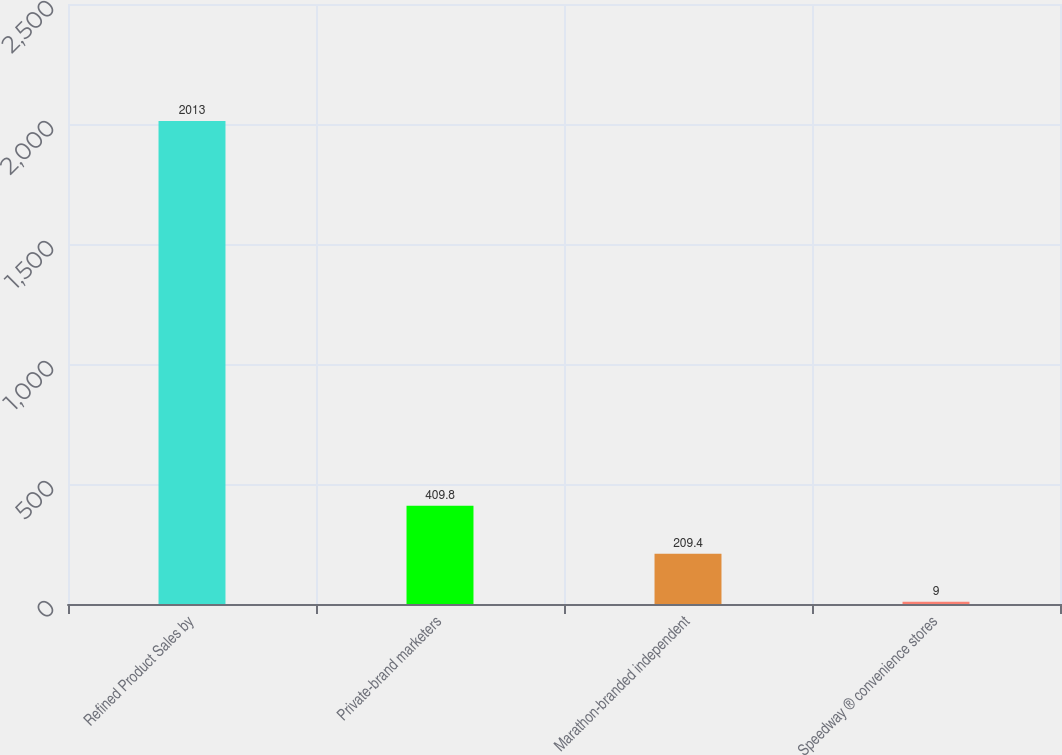<chart> <loc_0><loc_0><loc_500><loc_500><bar_chart><fcel>Refined Product Sales by<fcel>Private-brand marketers<fcel>Marathon-branded independent<fcel>Speedway ® convenience stores<nl><fcel>2013<fcel>409.8<fcel>209.4<fcel>9<nl></chart> 